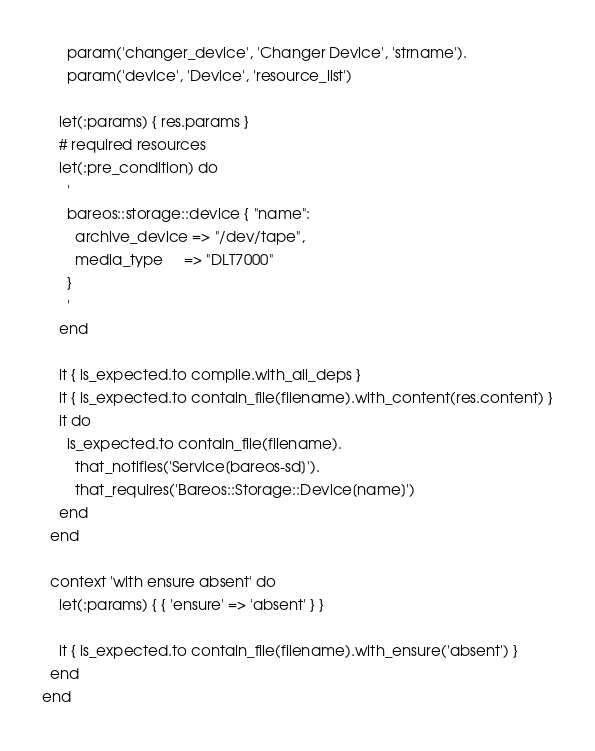<code> <loc_0><loc_0><loc_500><loc_500><_Ruby_>      param('changer_device', 'Changer Device', 'strname').
      param('device', 'Device', 'resource_list')

    let(:params) { res.params }
    # required resources
    let(:pre_condition) do
      '
      bareos::storage::device { "name":
        archive_device => "/dev/tape",
        media_type     => "DLT7000"
      }
      '
    end

    it { is_expected.to compile.with_all_deps }
    it { is_expected.to contain_file(filename).with_content(res.content) }
    it do
      is_expected.to contain_file(filename).
        that_notifies('Service[bareos-sd]').
        that_requires('Bareos::Storage::Device[name]')
    end
  end

  context 'with ensure absent' do
    let(:params) { { 'ensure' => 'absent' } }

    it { is_expected.to contain_file(filename).with_ensure('absent') }
  end
end
</code> 